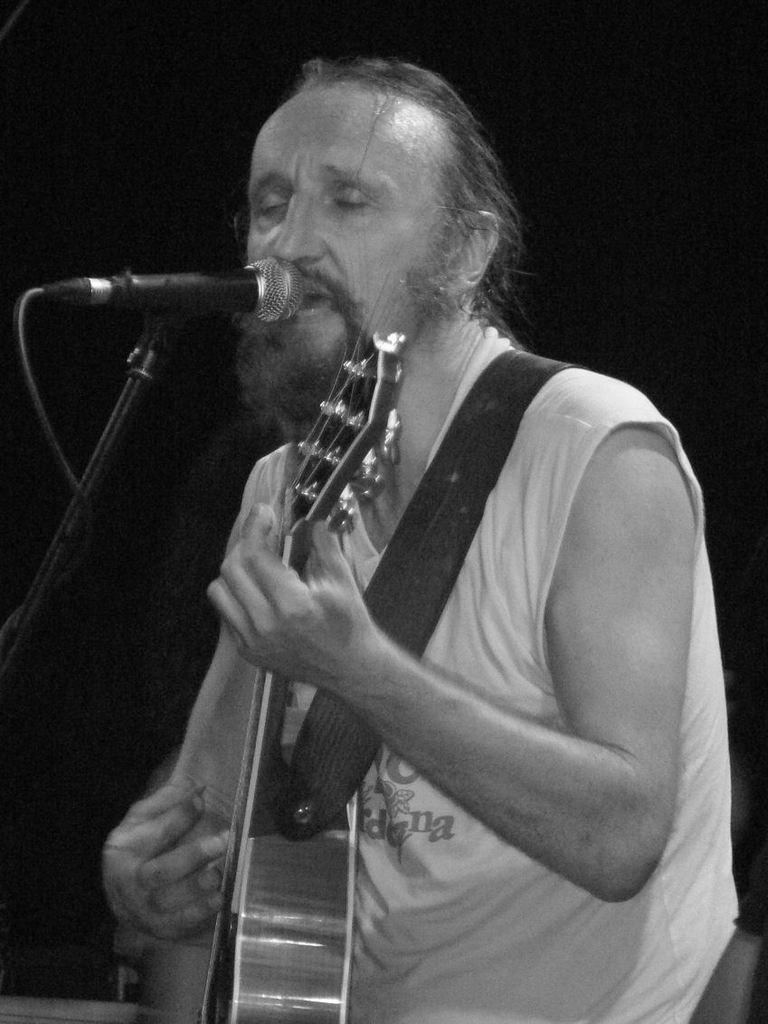What is the color scheme of the image? The image is black and white. What is the main subject of the image? There is a person in the image. What is the person doing in the image? The person is singing a song. What instrument is the person wearing? The person is wearing a guitar. What device is in front of the person? There is a microphone in front of the person. How many ants can be seen crawling on the guitar in the image? There are no ants visible in the image, as it features a person singing with a guitar and a microphone. 